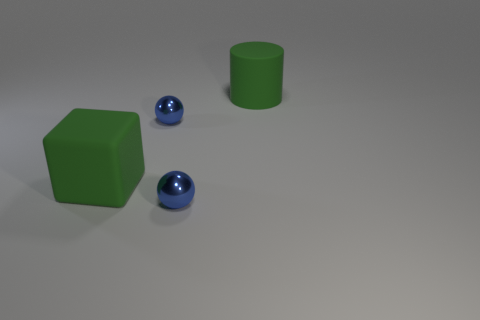Subtract 1 balls. How many balls are left? 1 Add 1 small gray metallic cylinders. How many objects exist? 5 Subtract all green cylinders. Subtract all small metallic spheres. How many objects are left? 1 Add 4 blue balls. How many blue balls are left? 6 Add 4 blue shiny spheres. How many blue shiny spheres exist? 6 Subtract 0 yellow blocks. How many objects are left? 4 Subtract all red cylinders. Subtract all purple cubes. How many cylinders are left? 1 Subtract all purple cylinders. How many purple balls are left? 0 